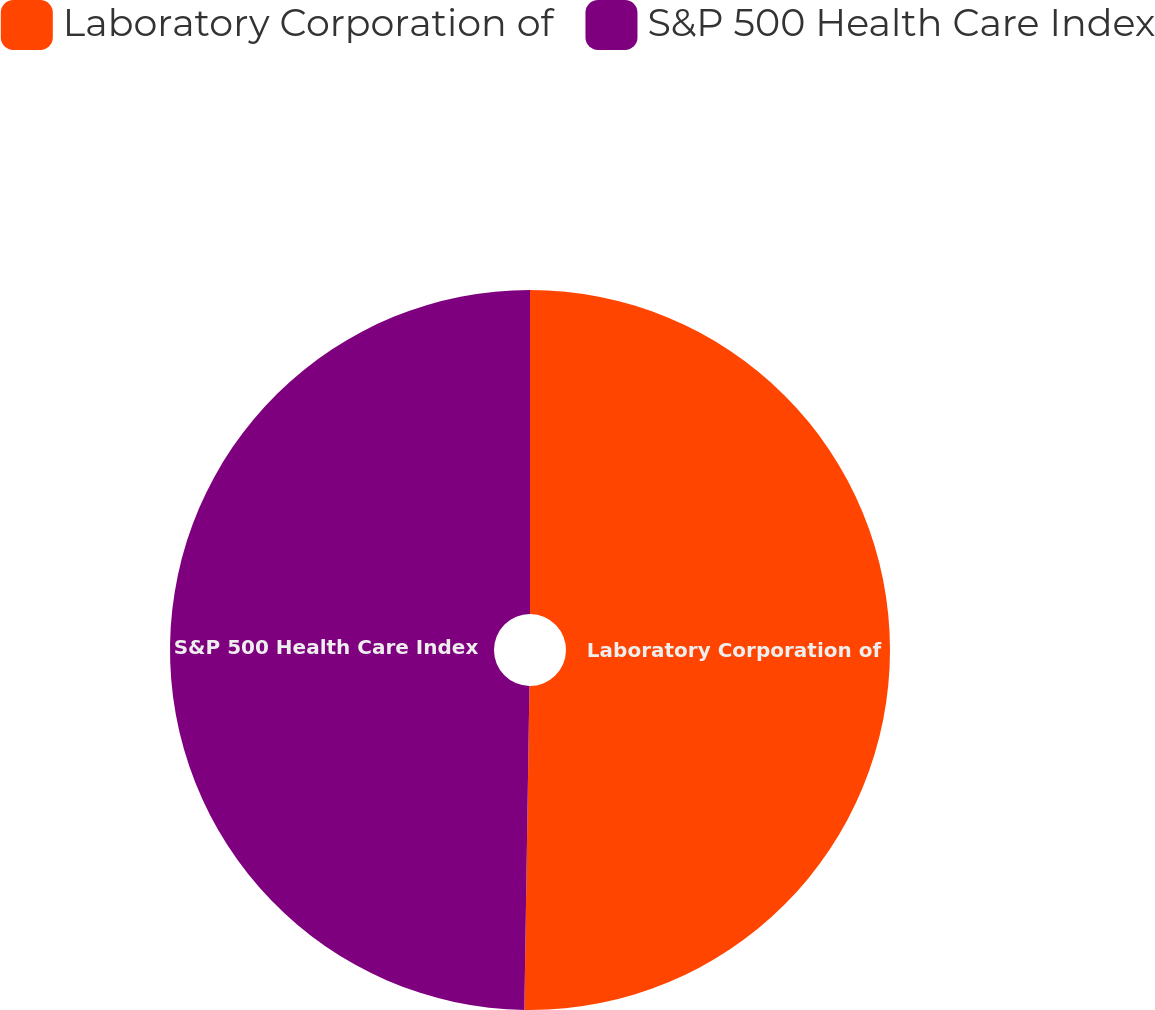<chart> <loc_0><loc_0><loc_500><loc_500><pie_chart><fcel>Laboratory Corporation of<fcel>S&P 500 Health Care Index<nl><fcel>50.25%<fcel>49.75%<nl></chart> 